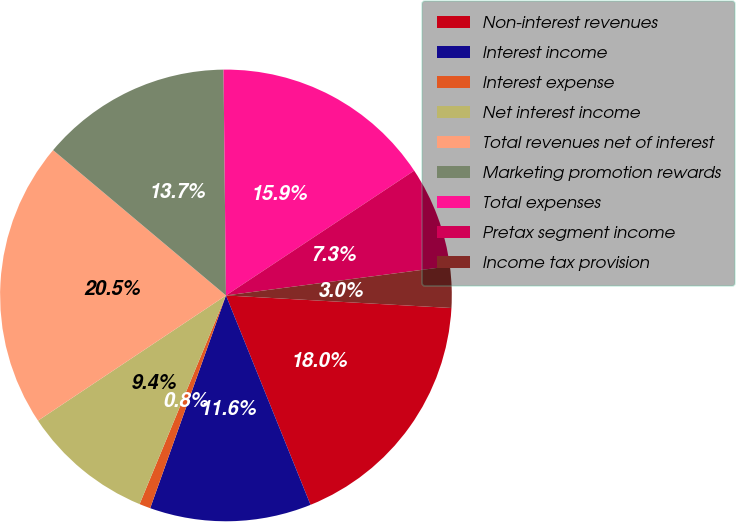Convert chart to OTSL. <chart><loc_0><loc_0><loc_500><loc_500><pie_chart><fcel>Non-interest revenues<fcel>Interest income<fcel>Interest expense<fcel>Net interest income<fcel>Total revenues net of interest<fcel>Marketing promotion rewards<fcel>Total expenses<fcel>Pretax segment income<fcel>Income tax provision<nl><fcel>18.0%<fcel>11.55%<fcel>0.8%<fcel>9.4%<fcel>20.47%<fcel>13.7%<fcel>15.85%<fcel>7.25%<fcel>2.95%<nl></chart> 